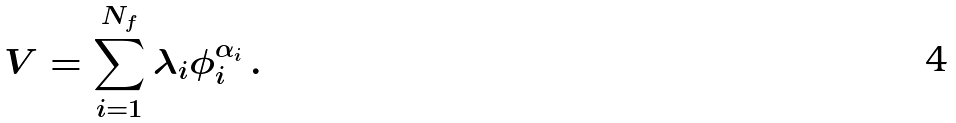<formula> <loc_0><loc_0><loc_500><loc_500>V = \sum _ { i = 1 } ^ { N _ { f } } \lambda _ { i } \phi _ { i } ^ { \alpha _ { i } } \, .</formula> 